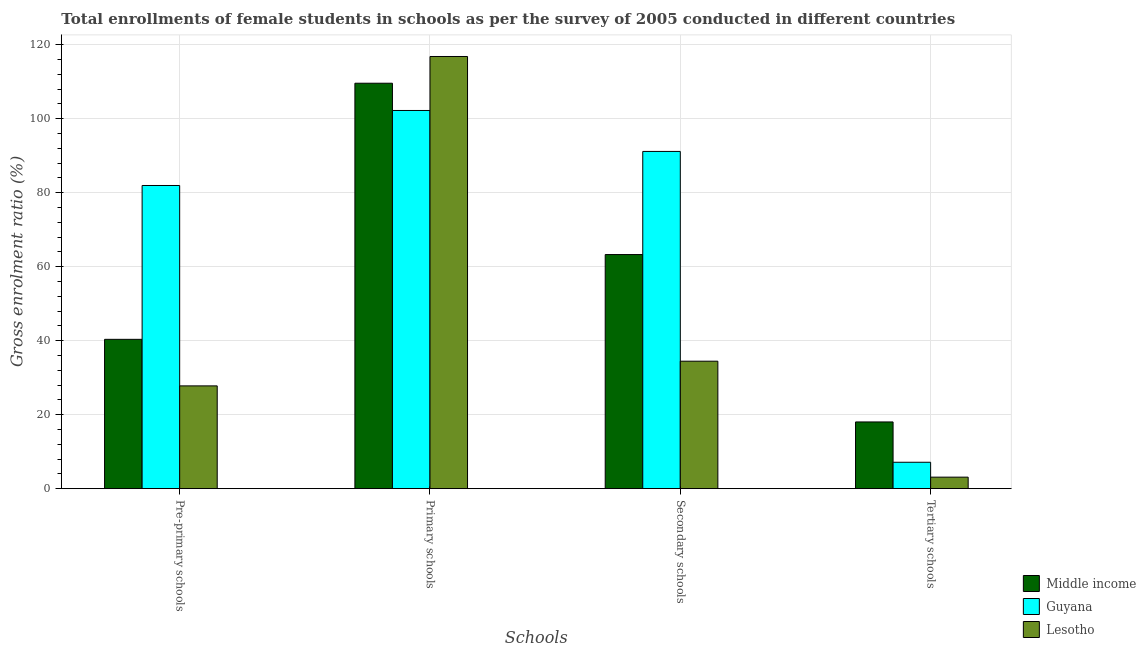How many different coloured bars are there?
Your answer should be compact. 3. Are the number of bars on each tick of the X-axis equal?
Your answer should be very brief. Yes. How many bars are there on the 1st tick from the left?
Make the answer very short. 3. What is the label of the 3rd group of bars from the left?
Provide a succinct answer. Secondary schools. What is the gross enrolment ratio(female) in primary schools in Guyana?
Your answer should be very brief. 102.21. Across all countries, what is the maximum gross enrolment ratio(female) in primary schools?
Provide a succinct answer. 116.8. Across all countries, what is the minimum gross enrolment ratio(female) in secondary schools?
Ensure brevity in your answer.  34.45. In which country was the gross enrolment ratio(female) in pre-primary schools maximum?
Provide a succinct answer. Guyana. In which country was the gross enrolment ratio(female) in tertiary schools minimum?
Your response must be concise. Lesotho. What is the total gross enrolment ratio(female) in primary schools in the graph?
Your answer should be very brief. 328.6. What is the difference between the gross enrolment ratio(female) in primary schools in Lesotho and that in Middle income?
Your answer should be compact. 7.23. What is the difference between the gross enrolment ratio(female) in tertiary schools in Lesotho and the gross enrolment ratio(female) in pre-primary schools in Guyana?
Offer a terse response. -78.82. What is the average gross enrolment ratio(female) in secondary schools per country?
Give a very brief answer. 62.96. What is the difference between the gross enrolment ratio(female) in secondary schools and gross enrolment ratio(female) in pre-primary schools in Guyana?
Make the answer very short. 9.21. In how many countries, is the gross enrolment ratio(female) in pre-primary schools greater than 8 %?
Provide a succinct answer. 3. What is the ratio of the gross enrolment ratio(female) in tertiary schools in Middle income to that in Guyana?
Provide a short and direct response. 2.53. Is the gross enrolment ratio(female) in pre-primary schools in Guyana less than that in Lesotho?
Provide a succinct answer. No. Is the difference between the gross enrolment ratio(female) in primary schools in Middle income and Guyana greater than the difference between the gross enrolment ratio(female) in tertiary schools in Middle income and Guyana?
Make the answer very short. No. What is the difference between the highest and the second highest gross enrolment ratio(female) in pre-primary schools?
Your answer should be compact. 41.58. What is the difference between the highest and the lowest gross enrolment ratio(female) in secondary schools?
Your response must be concise. 56.69. In how many countries, is the gross enrolment ratio(female) in pre-primary schools greater than the average gross enrolment ratio(female) in pre-primary schools taken over all countries?
Your response must be concise. 1. Is the sum of the gross enrolment ratio(female) in secondary schools in Lesotho and Guyana greater than the maximum gross enrolment ratio(female) in pre-primary schools across all countries?
Your response must be concise. Yes. What does the 3rd bar from the left in Pre-primary schools represents?
Make the answer very short. Lesotho. What does the 3rd bar from the right in Tertiary schools represents?
Ensure brevity in your answer.  Middle income. How many bars are there?
Make the answer very short. 12. Are all the bars in the graph horizontal?
Make the answer very short. No. How many countries are there in the graph?
Provide a short and direct response. 3. Does the graph contain any zero values?
Provide a succinct answer. No. Does the graph contain grids?
Give a very brief answer. Yes. What is the title of the graph?
Keep it short and to the point. Total enrollments of female students in schools as per the survey of 2005 conducted in different countries. Does "Small states" appear as one of the legend labels in the graph?
Give a very brief answer. No. What is the label or title of the X-axis?
Make the answer very short. Schools. What is the label or title of the Y-axis?
Your answer should be very brief. Gross enrolment ratio (%). What is the Gross enrolment ratio (%) in Middle income in Pre-primary schools?
Provide a succinct answer. 40.36. What is the Gross enrolment ratio (%) in Guyana in Pre-primary schools?
Provide a succinct answer. 81.94. What is the Gross enrolment ratio (%) of Lesotho in Pre-primary schools?
Make the answer very short. 27.78. What is the Gross enrolment ratio (%) of Middle income in Primary schools?
Keep it short and to the point. 109.58. What is the Gross enrolment ratio (%) of Guyana in Primary schools?
Provide a succinct answer. 102.21. What is the Gross enrolment ratio (%) in Lesotho in Primary schools?
Your answer should be very brief. 116.8. What is the Gross enrolment ratio (%) in Middle income in Secondary schools?
Offer a very short reply. 63.27. What is the Gross enrolment ratio (%) in Guyana in Secondary schools?
Offer a terse response. 91.15. What is the Gross enrolment ratio (%) of Lesotho in Secondary schools?
Your answer should be very brief. 34.45. What is the Gross enrolment ratio (%) in Middle income in Tertiary schools?
Give a very brief answer. 18.03. What is the Gross enrolment ratio (%) in Guyana in Tertiary schools?
Offer a terse response. 7.14. What is the Gross enrolment ratio (%) of Lesotho in Tertiary schools?
Offer a terse response. 3.11. Across all Schools, what is the maximum Gross enrolment ratio (%) of Middle income?
Give a very brief answer. 109.58. Across all Schools, what is the maximum Gross enrolment ratio (%) of Guyana?
Give a very brief answer. 102.21. Across all Schools, what is the maximum Gross enrolment ratio (%) of Lesotho?
Your answer should be compact. 116.8. Across all Schools, what is the minimum Gross enrolment ratio (%) in Middle income?
Make the answer very short. 18.03. Across all Schools, what is the minimum Gross enrolment ratio (%) of Guyana?
Offer a very short reply. 7.14. Across all Schools, what is the minimum Gross enrolment ratio (%) in Lesotho?
Ensure brevity in your answer.  3.11. What is the total Gross enrolment ratio (%) in Middle income in the graph?
Offer a very short reply. 231.25. What is the total Gross enrolment ratio (%) of Guyana in the graph?
Offer a terse response. 282.43. What is the total Gross enrolment ratio (%) in Lesotho in the graph?
Offer a very short reply. 182.15. What is the difference between the Gross enrolment ratio (%) of Middle income in Pre-primary schools and that in Primary schools?
Ensure brevity in your answer.  -69.22. What is the difference between the Gross enrolment ratio (%) of Guyana in Pre-primary schools and that in Primary schools?
Keep it short and to the point. -20.27. What is the difference between the Gross enrolment ratio (%) of Lesotho in Pre-primary schools and that in Primary schools?
Your answer should be very brief. -89.02. What is the difference between the Gross enrolment ratio (%) of Middle income in Pre-primary schools and that in Secondary schools?
Ensure brevity in your answer.  -22.91. What is the difference between the Gross enrolment ratio (%) in Guyana in Pre-primary schools and that in Secondary schools?
Keep it short and to the point. -9.21. What is the difference between the Gross enrolment ratio (%) in Lesotho in Pre-primary schools and that in Secondary schools?
Make the answer very short. -6.67. What is the difference between the Gross enrolment ratio (%) of Middle income in Pre-primary schools and that in Tertiary schools?
Provide a succinct answer. 22.33. What is the difference between the Gross enrolment ratio (%) of Guyana in Pre-primary schools and that in Tertiary schools?
Provide a short and direct response. 74.8. What is the difference between the Gross enrolment ratio (%) in Lesotho in Pre-primary schools and that in Tertiary schools?
Offer a very short reply. 24.67. What is the difference between the Gross enrolment ratio (%) in Middle income in Primary schools and that in Secondary schools?
Provide a succinct answer. 46.31. What is the difference between the Gross enrolment ratio (%) of Guyana in Primary schools and that in Secondary schools?
Provide a short and direct response. 11.07. What is the difference between the Gross enrolment ratio (%) of Lesotho in Primary schools and that in Secondary schools?
Keep it short and to the point. 82.35. What is the difference between the Gross enrolment ratio (%) in Middle income in Primary schools and that in Tertiary schools?
Your response must be concise. 91.55. What is the difference between the Gross enrolment ratio (%) of Guyana in Primary schools and that in Tertiary schools?
Give a very brief answer. 95.07. What is the difference between the Gross enrolment ratio (%) in Lesotho in Primary schools and that in Tertiary schools?
Your response must be concise. 113.69. What is the difference between the Gross enrolment ratio (%) of Middle income in Secondary schools and that in Tertiary schools?
Your answer should be very brief. 45.24. What is the difference between the Gross enrolment ratio (%) of Guyana in Secondary schools and that in Tertiary schools?
Keep it short and to the point. 84.01. What is the difference between the Gross enrolment ratio (%) in Lesotho in Secondary schools and that in Tertiary schools?
Make the answer very short. 31.34. What is the difference between the Gross enrolment ratio (%) in Middle income in Pre-primary schools and the Gross enrolment ratio (%) in Guyana in Primary schools?
Ensure brevity in your answer.  -61.85. What is the difference between the Gross enrolment ratio (%) of Middle income in Pre-primary schools and the Gross enrolment ratio (%) of Lesotho in Primary schools?
Your answer should be very brief. -76.45. What is the difference between the Gross enrolment ratio (%) of Guyana in Pre-primary schools and the Gross enrolment ratio (%) of Lesotho in Primary schools?
Your answer should be very brief. -34.87. What is the difference between the Gross enrolment ratio (%) of Middle income in Pre-primary schools and the Gross enrolment ratio (%) of Guyana in Secondary schools?
Ensure brevity in your answer.  -50.79. What is the difference between the Gross enrolment ratio (%) in Middle income in Pre-primary schools and the Gross enrolment ratio (%) in Lesotho in Secondary schools?
Give a very brief answer. 5.91. What is the difference between the Gross enrolment ratio (%) of Guyana in Pre-primary schools and the Gross enrolment ratio (%) of Lesotho in Secondary schools?
Ensure brevity in your answer.  47.49. What is the difference between the Gross enrolment ratio (%) in Middle income in Pre-primary schools and the Gross enrolment ratio (%) in Guyana in Tertiary schools?
Offer a very short reply. 33.22. What is the difference between the Gross enrolment ratio (%) in Middle income in Pre-primary schools and the Gross enrolment ratio (%) in Lesotho in Tertiary schools?
Provide a short and direct response. 37.25. What is the difference between the Gross enrolment ratio (%) in Guyana in Pre-primary schools and the Gross enrolment ratio (%) in Lesotho in Tertiary schools?
Your answer should be very brief. 78.82. What is the difference between the Gross enrolment ratio (%) in Middle income in Primary schools and the Gross enrolment ratio (%) in Guyana in Secondary schools?
Provide a short and direct response. 18.43. What is the difference between the Gross enrolment ratio (%) in Middle income in Primary schools and the Gross enrolment ratio (%) in Lesotho in Secondary schools?
Provide a succinct answer. 75.13. What is the difference between the Gross enrolment ratio (%) in Guyana in Primary schools and the Gross enrolment ratio (%) in Lesotho in Secondary schools?
Provide a succinct answer. 67.76. What is the difference between the Gross enrolment ratio (%) in Middle income in Primary schools and the Gross enrolment ratio (%) in Guyana in Tertiary schools?
Ensure brevity in your answer.  102.44. What is the difference between the Gross enrolment ratio (%) of Middle income in Primary schools and the Gross enrolment ratio (%) of Lesotho in Tertiary schools?
Provide a succinct answer. 106.46. What is the difference between the Gross enrolment ratio (%) in Guyana in Primary schools and the Gross enrolment ratio (%) in Lesotho in Tertiary schools?
Ensure brevity in your answer.  99.1. What is the difference between the Gross enrolment ratio (%) in Middle income in Secondary schools and the Gross enrolment ratio (%) in Guyana in Tertiary schools?
Give a very brief answer. 56.13. What is the difference between the Gross enrolment ratio (%) in Middle income in Secondary schools and the Gross enrolment ratio (%) in Lesotho in Tertiary schools?
Your answer should be very brief. 60.16. What is the difference between the Gross enrolment ratio (%) of Guyana in Secondary schools and the Gross enrolment ratio (%) of Lesotho in Tertiary schools?
Offer a very short reply. 88.03. What is the average Gross enrolment ratio (%) in Middle income per Schools?
Provide a succinct answer. 57.81. What is the average Gross enrolment ratio (%) in Guyana per Schools?
Keep it short and to the point. 70.61. What is the average Gross enrolment ratio (%) in Lesotho per Schools?
Offer a terse response. 45.54. What is the difference between the Gross enrolment ratio (%) of Middle income and Gross enrolment ratio (%) of Guyana in Pre-primary schools?
Provide a succinct answer. -41.58. What is the difference between the Gross enrolment ratio (%) in Middle income and Gross enrolment ratio (%) in Lesotho in Pre-primary schools?
Your answer should be compact. 12.58. What is the difference between the Gross enrolment ratio (%) in Guyana and Gross enrolment ratio (%) in Lesotho in Pre-primary schools?
Provide a succinct answer. 54.16. What is the difference between the Gross enrolment ratio (%) of Middle income and Gross enrolment ratio (%) of Guyana in Primary schools?
Your answer should be compact. 7.37. What is the difference between the Gross enrolment ratio (%) of Middle income and Gross enrolment ratio (%) of Lesotho in Primary schools?
Provide a short and direct response. -7.23. What is the difference between the Gross enrolment ratio (%) of Guyana and Gross enrolment ratio (%) of Lesotho in Primary schools?
Your response must be concise. -14.59. What is the difference between the Gross enrolment ratio (%) in Middle income and Gross enrolment ratio (%) in Guyana in Secondary schools?
Provide a succinct answer. -27.87. What is the difference between the Gross enrolment ratio (%) of Middle income and Gross enrolment ratio (%) of Lesotho in Secondary schools?
Offer a very short reply. 28.82. What is the difference between the Gross enrolment ratio (%) of Guyana and Gross enrolment ratio (%) of Lesotho in Secondary schools?
Give a very brief answer. 56.69. What is the difference between the Gross enrolment ratio (%) in Middle income and Gross enrolment ratio (%) in Guyana in Tertiary schools?
Provide a short and direct response. 10.89. What is the difference between the Gross enrolment ratio (%) of Middle income and Gross enrolment ratio (%) of Lesotho in Tertiary schools?
Your answer should be compact. 14.92. What is the difference between the Gross enrolment ratio (%) in Guyana and Gross enrolment ratio (%) in Lesotho in Tertiary schools?
Make the answer very short. 4.02. What is the ratio of the Gross enrolment ratio (%) in Middle income in Pre-primary schools to that in Primary schools?
Your response must be concise. 0.37. What is the ratio of the Gross enrolment ratio (%) in Guyana in Pre-primary schools to that in Primary schools?
Provide a succinct answer. 0.8. What is the ratio of the Gross enrolment ratio (%) in Lesotho in Pre-primary schools to that in Primary schools?
Your answer should be very brief. 0.24. What is the ratio of the Gross enrolment ratio (%) in Middle income in Pre-primary schools to that in Secondary schools?
Give a very brief answer. 0.64. What is the ratio of the Gross enrolment ratio (%) in Guyana in Pre-primary schools to that in Secondary schools?
Your answer should be very brief. 0.9. What is the ratio of the Gross enrolment ratio (%) of Lesotho in Pre-primary schools to that in Secondary schools?
Your answer should be very brief. 0.81. What is the ratio of the Gross enrolment ratio (%) in Middle income in Pre-primary schools to that in Tertiary schools?
Give a very brief answer. 2.24. What is the ratio of the Gross enrolment ratio (%) of Guyana in Pre-primary schools to that in Tertiary schools?
Provide a succinct answer. 11.48. What is the ratio of the Gross enrolment ratio (%) of Lesotho in Pre-primary schools to that in Tertiary schools?
Provide a succinct answer. 8.92. What is the ratio of the Gross enrolment ratio (%) in Middle income in Primary schools to that in Secondary schools?
Give a very brief answer. 1.73. What is the ratio of the Gross enrolment ratio (%) of Guyana in Primary schools to that in Secondary schools?
Provide a short and direct response. 1.12. What is the ratio of the Gross enrolment ratio (%) in Lesotho in Primary schools to that in Secondary schools?
Offer a very short reply. 3.39. What is the ratio of the Gross enrolment ratio (%) of Middle income in Primary schools to that in Tertiary schools?
Your answer should be very brief. 6.08. What is the ratio of the Gross enrolment ratio (%) of Guyana in Primary schools to that in Tertiary schools?
Your response must be concise. 14.32. What is the ratio of the Gross enrolment ratio (%) in Lesotho in Primary schools to that in Tertiary schools?
Offer a terse response. 37.5. What is the ratio of the Gross enrolment ratio (%) in Middle income in Secondary schools to that in Tertiary schools?
Make the answer very short. 3.51. What is the ratio of the Gross enrolment ratio (%) of Guyana in Secondary schools to that in Tertiary schools?
Ensure brevity in your answer.  12.77. What is the ratio of the Gross enrolment ratio (%) in Lesotho in Secondary schools to that in Tertiary schools?
Provide a short and direct response. 11.06. What is the difference between the highest and the second highest Gross enrolment ratio (%) in Middle income?
Your response must be concise. 46.31. What is the difference between the highest and the second highest Gross enrolment ratio (%) of Guyana?
Your response must be concise. 11.07. What is the difference between the highest and the second highest Gross enrolment ratio (%) of Lesotho?
Offer a terse response. 82.35. What is the difference between the highest and the lowest Gross enrolment ratio (%) of Middle income?
Your answer should be compact. 91.55. What is the difference between the highest and the lowest Gross enrolment ratio (%) in Guyana?
Keep it short and to the point. 95.07. What is the difference between the highest and the lowest Gross enrolment ratio (%) in Lesotho?
Provide a succinct answer. 113.69. 